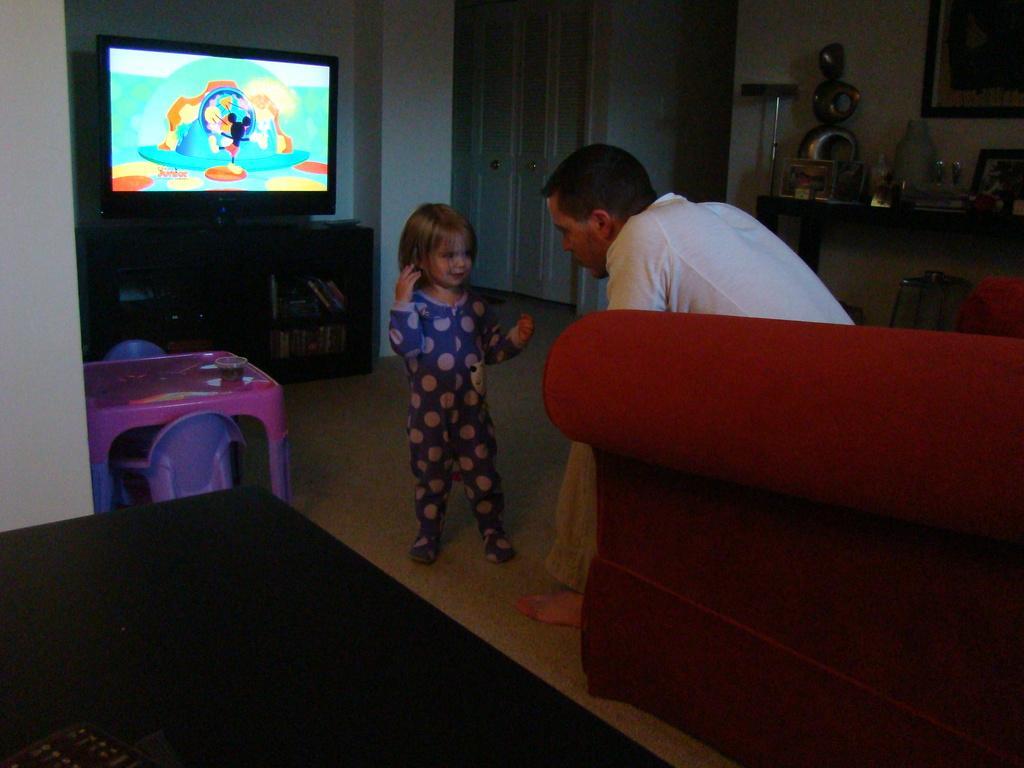In one or two sentences, can you explain what this image depicts? In this image i can see there is a girl and a man is sitting on a couch in front of a TV. I can also see there is a table on the floor. 